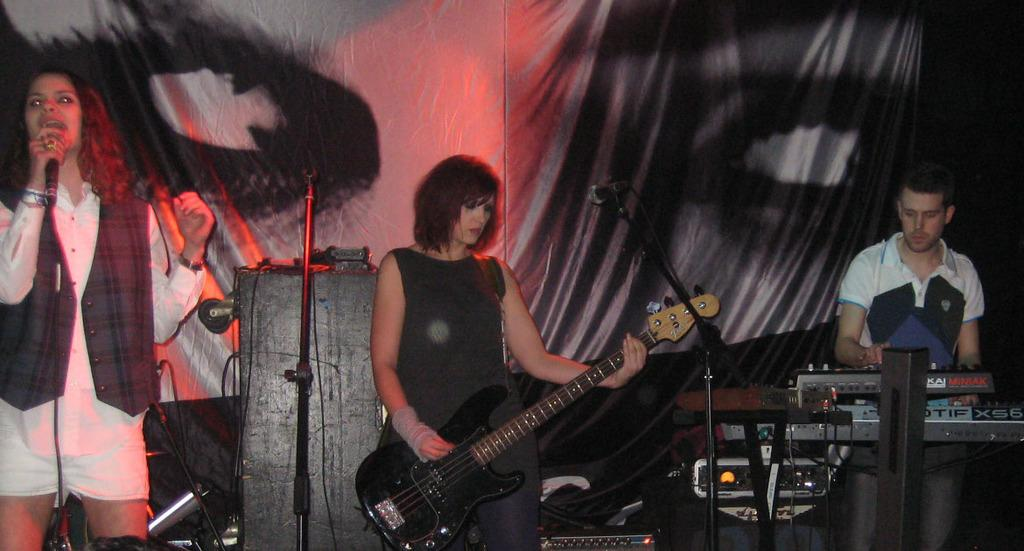How many people are in the image? There are three people in the image. What musical instrument can be seen in the image? There is a guitar in the image. What equipment is present for amplifying sound in the image? There are microphones (mics) in the image. What type of electronic devices are visible in the image? There are devices in the image. What type of wiring is present in the image? There are cables in the image. What type of fabric is present in the image? There is cloth in the image. Can you describe any unspecified objects in the image? There are some unspecified objects in the image. What type of celery is being used as a microphone stand in the image? There is no celery present in the image, and therefore no such use can be observed. Can you tell me how the truck is being used in the image? There is no truck present in the image. 